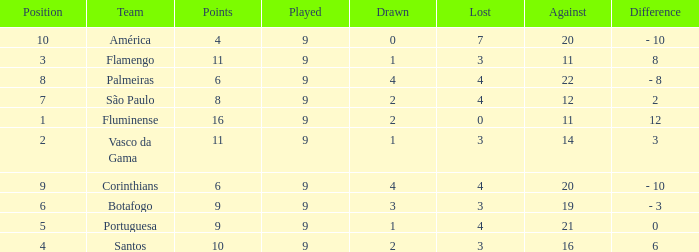Which average Played has a Drawn smaller than 1, and Points larger than 4? None. 